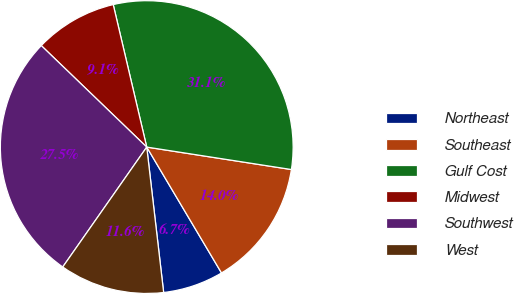Convert chart. <chart><loc_0><loc_0><loc_500><loc_500><pie_chart><fcel>Northeast<fcel>Southeast<fcel>Gulf Cost<fcel>Midwest<fcel>Southwest<fcel>West<nl><fcel>6.69%<fcel>14.02%<fcel>31.13%<fcel>9.13%<fcel>27.47%<fcel>11.57%<nl></chart> 